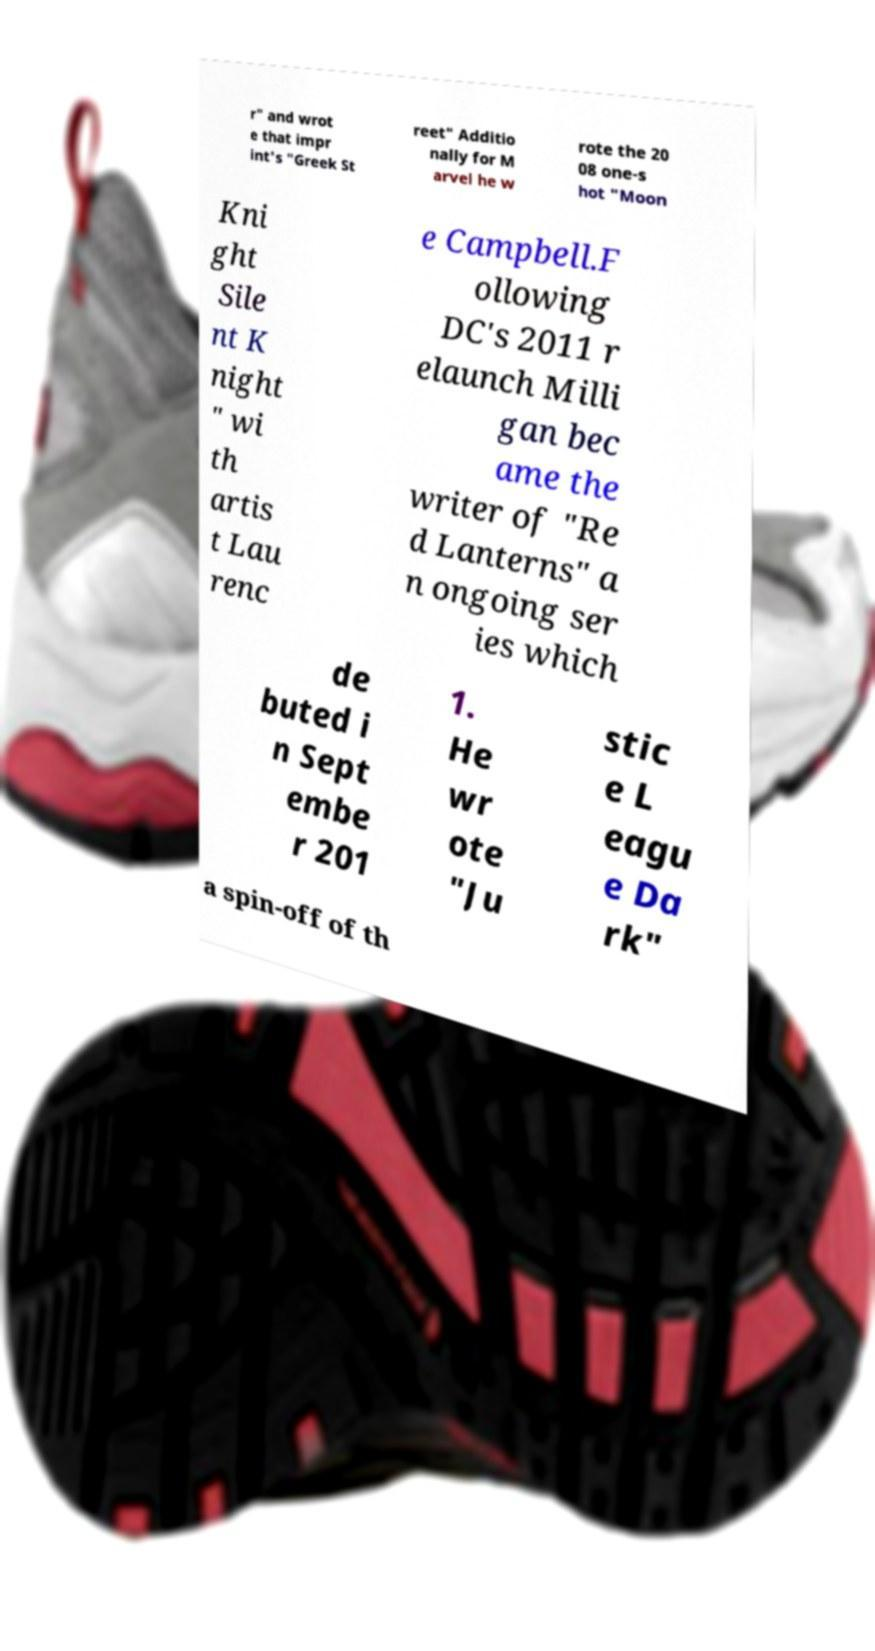Could you assist in decoding the text presented in this image and type it out clearly? r" and wrot e that impr int's "Greek St reet" Additio nally for M arvel he w rote the 20 08 one-s hot "Moon Kni ght Sile nt K night " wi th artis t Lau renc e Campbell.F ollowing DC's 2011 r elaunch Milli gan bec ame the writer of "Re d Lanterns" a n ongoing ser ies which de buted i n Sept embe r 201 1. He wr ote "Ju stic e L eagu e Da rk" a spin-off of th 